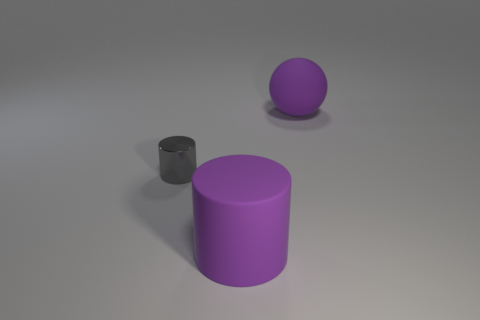Is the color of the small cylinder the same as the rubber ball?
Make the answer very short. No. What number of objects are large purple rubber objects in front of the shiny cylinder or purple metal things?
Give a very brief answer. 1. What number of tiny gray shiny objects are behind the rubber object behind the cylinder that is in front of the tiny cylinder?
Provide a short and direct response. 0. Are there any other things that are the same size as the purple rubber cylinder?
Your answer should be compact. Yes. What is the shape of the large matte thing behind the object that is to the left of the matte object that is in front of the tiny gray metallic cylinder?
Ensure brevity in your answer.  Sphere. How many other things are there of the same color as the ball?
Your answer should be compact. 1. There is a matte thing that is behind the gray object behind the big cylinder; what is its shape?
Your answer should be compact. Sphere. What number of spheres are behind the large sphere?
Offer a very short reply. 0. Are there any large yellow cubes that have the same material as the large purple sphere?
Offer a terse response. No. There is a thing that is the same size as the purple matte ball; what material is it?
Offer a very short reply. Rubber. 